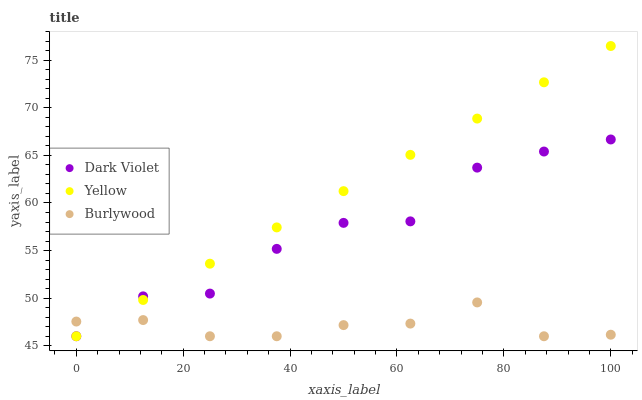Does Burlywood have the minimum area under the curve?
Answer yes or no. Yes. Does Yellow have the maximum area under the curve?
Answer yes or no. Yes. Does Dark Violet have the minimum area under the curve?
Answer yes or no. No. Does Dark Violet have the maximum area under the curve?
Answer yes or no. No. Is Yellow the smoothest?
Answer yes or no. Yes. Is Dark Violet the roughest?
Answer yes or no. Yes. Is Dark Violet the smoothest?
Answer yes or no. No. Is Yellow the roughest?
Answer yes or no. No. Does Burlywood have the lowest value?
Answer yes or no. Yes. Does Yellow have the highest value?
Answer yes or no. Yes. Does Dark Violet have the highest value?
Answer yes or no. No. Does Dark Violet intersect Burlywood?
Answer yes or no. Yes. Is Dark Violet less than Burlywood?
Answer yes or no. No. Is Dark Violet greater than Burlywood?
Answer yes or no. No. 